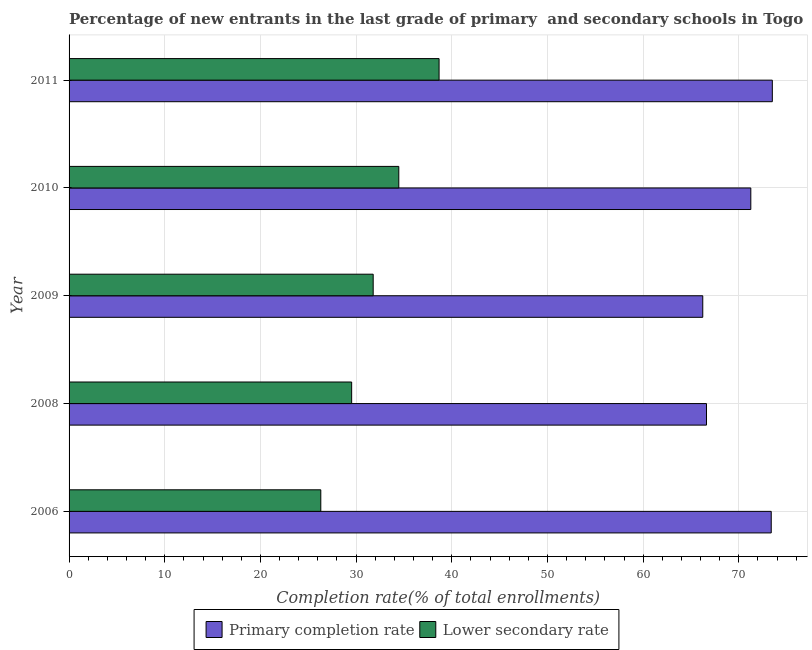Are the number of bars per tick equal to the number of legend labels?
Your answer should be very brief. Yes. How many bars are there on the 2nd tick from the top?
Offer a terse response. 2. How many bars are there on the 2nd tick from the bottom?
Provide a succinct answer. 2. What is the label of the 5th group of bars from the top?
Your response must be concise. 2006. In how many cases, is the number of bars for a given year not equal to the number of legend labels?
Provide a short and direct response. 0. What is the completion rate in primary schools in 2008?
Offer a terse response. 66.62. Across all years, what is the maximum completion rate in primary schools?
Your answer should be very brief. 73.5. Across all years, what is the minimum completion rate in secondary schools?
Offer a very short reply. 26.31. In which year was the completion rate in secondary schools maximum?
Give a very brief answer. 2011. What is the total completion rate in secondary schools in the graph?
Offer a very short reply. 160.77. What is the difference between the completion rate in secondary schools in 2006 and that in 2011?
Keep it short and to the point. -12.36. What is the difference between the completion rate in primary schools in 2008 and the completion rate in secondary schools in 2011?
Your answer should be very brief. 27.95. What is the average completion rate in primary schools per year?
Give a very brief answer. 70.2. In the year 2009, what is the difference between the completion rate in primary schools and completion rate in secondary schools?
Make the answer very short. 34.45. What is the ratio of the completion rate in primary schools in 2006 to that in 2008?
Ensure brevity in your answer.  1.1. Is the difference between the completion rate in secondary schools in 2006 and 2009 greater than the difference between the completion rate in primary schools in 2006 and 2009?
Offer a terse response. No. What is the difference between the highest and the second highest completion rate in secondary schools?
Offer a terse response. 4.21. What is the difference between the highest and the lowest completion rate in primary schools?
Keep it short and to the point. 7.27. What does the 2nd bar from the top in 2008 represents?
Make the answer very short. Primary completion rate. What does the 2nd bar from the bottom in 2008 represents?
Your response must be concise. Lower secondary rate. How many bars are there?
Ensure brevity in your answer.  10. How many years are there in the graph?
Make the answer very short. 5. Does the graph contain any zero values?
Give a very brief answer. No. Does the graph contain grids?
Give a very brief answer. Yes. Where does the legend appear in the graph?
Your answer should be very brief. Bottom center. How many legend labels are there?
Make the answer very short. 2. What is the title of the graph?
Offer a terse response. Percentage of new entrants in the last grade of primary  and secondary schools in Togo. What is the label or title of the X-axis?
Make the answer very short. Completion rate(% of total enrollments). What is the label or title of the Y-axis?
Provide a short and direct response. Year. What is the Completion rate(% of total enrollments) in Primary completion rate in 2006?
Give a very brief answer. 73.39. What is the Completion rate(% of total enrollments) in Lower secondary rate in 2006?
Your answer should be very brief. 26.31. What is the Completion rate(% of total enrollments) in Primary completion rate in 2008?
Make the answer very short. 66.62. What is the Completion rate(% of total enrollments) in Lower secondary rate in 2008?
Give a very brief answer. 29.54. What is the Completion rate(% of total enrollments) in Primary completion rate in 2009?
Offer a terse response. 66.23. What is the Completion rate(% of total enrollments) of Lower secondary rate in 2009?
Offer a very short reply. 31.79. What is the Completion rate(% of total enrollments) in Primary completion rate in 2010?
Your answer should be compact. 71.25. What is the Completion rate(% of total enrollments) of Lower secondary rate in 2010?
Your answer should be compact. 34.46. What is the Completion rate(% of total enrollments) in Primary completion rate in 2011?
Provide a succinct answer. 73.5. What is the Completion rate(% of total enrollments) in Lower secondary rate in 2011?
Your answer should be compact. 38.67. Across all years, what is the maximum Completion rate(% of total enrollments) in Primary completion rate?
Ensure brevity in your answer.  73.5. Across all years, what is the maximum Completion rate(% of total enrollments) of Lower secondary rate?
Make the answer very short. 38.67. Across all years, what is the minimum Completion rate(% of total enrollments) in Primary completion rate?
Provide a short and direct response. 66.23. Across all years, what is the minimum Completion rate(% of total enrollments) of Lower secondary rate?
Ensure brevity in your answer.  26.31. What is the total Completion rate(% of total enrollments) in Primary completion rate in the graph?
Provide a short and direct response. 351. What is the total Completion rate(% of total enrollments) of Lower secondary rate in the graph?
Offer a very short reply. 160.77. What is the difference between the Completion rate(% of total enrollments) of Primary completion rate in 2006 and that in 2008?
Provide a short and direct response. 6.77. What is the difference between the Completion rate(% of total enrollments) of Lower secondary rate in 2006 and that in 2008?
Offer a terse response. -3.23. What is the difference between the Completion rate(% of total enrollments) in Primary completion rate in 2006 and that in 2009?
Keep it short and to the point. 7.16. What is the difference between the Completion rate(% of total enrollments) of Lower secondary rate in 2006 and that in 2009?
Give a very brief answer. -5.48. What is the difference between the Completion rate(% of total enrollments) in Primary completion rate in 2006 and that in 2010?
Your response must be concise. 2.13. What is the difference between the Completion rate(% of total enrollments) of Lower secondary rate in 2006 and that in 2010?
Offer a very short reply. -8.15. What is the difference between the Completion rate(% of total enrollments) of Primary completion rate in 2006 and that in 2011?
Ensure brevity in your answer.  -0.11. What is the difference between the Completion rate(% of total enrollments) in Lower secondary rate in 2006 and that in 2011?
Keep it short and to the point. -12.36. What is the difference between the Completion rate(% of total enrollments) of Primary completion rate in 2008 and that in 2009?
Keep it short and to the point. 0.39. What is the difference between the Completion rate(% of total enrollments) of Lower secondary rate in 2008 and that in 2009?
Offer a terse response. -2.25. What is the difference between the Completion rate(% of total enrollments) in Primary completion rate in 2008 and that in 2010?
Offer a terse response. -4.63. What is the difference between the Completion rate(% of total enrollments) in Lower secondary rate in 2008 and that in 2010?
Your answer should be very brief. -4.93. What is the difference between the Completion rate(% of total enrollments) of Primary completion rate in 2008 and that in 2011?
Provide a short and direct response. -6.88. What is the difference between the Completion rate(% of total enrollments) in Lower secondary rate in 2008 and that in 2011?
Your answer should be compact. -9.14. What is the difference between the Completion rate(% of total enrollments) of Primary completion rate in 2009 and that in 2010?
Your response must be concise. -5.02. What is the difference between the Completion rate(% of total enrollments) in Lower secondary rate in 2009 and that in 2010?
Provide a succinct answer. -2.68. What is the difference between the Completion rate(% of total enrollments) of Primary completion rate in 2009 and that in 2011?
Ensure brevity in your answer.  -7.27. What is the difference between the Completion rate(% of total enrollments) in Lower secondary rate in 2009 and that in 2011?
Provide a succinct answer. -6.89. What is the difference between the Completion rate(% of total enrollments) in Primary completion rate in 2010 and that in 2011?
Provide a short and direct response. -2.25. What is the difference between the Completion rate(% of total enrollments) in Lower secondary rate in 2010 and that in 2011?
Your answer should be compact. -4.21. What is the difference between the Completion rate(% of total enrollments) in Primary completion rate in 2006 and the Completion rate(% of total enrollments) in Lower secondary rate in 2008?
Offer a very short reply. 43.85. What is the difference between the Completion rate(% of total enrollments) in Primary completion rate in 2006 and the Completion rate(% of total enrollments) in Lower secondary rate in 2009?
Keep it short and to the point. 41.6. What is the difference between the Completion rate(% of total enrollments) of Primary completion rate in 2006 and the Completion rate(% of total enrollments) of Lower secondary rate in 2010?
Make the answer very short. 38.93. What is the difference between the Completion rate(% of total enrollments) of Primary completion rate in 2006 and the Completion rate(% of total enrollments) of Lower secondary rate in 2011?
Ensure brevity in your answer.  34.72. What is the difference between the Completion rate(% of total enrollments) in Primary completion rate in 2008 and the Completion rate(% of total enrollments) in Lower secondary rate in 2009?
Provide a succinct answer. 34.84. What is the difference between the Completion rate(% of total enrollments) in Primary completion rate in 2008 and the Completion rate(% of total enrollments) in Lower secondary rate in 2010?
Offer a very short reply. 32.16. What is the difference between the Completion rate(% of total enrollments) in Primary completion rate in 2008 and the Completion rate(% of total enrollments) in Lower secondary rate in 2011?
Your answer should be very brief. 27.95. What is the difference between the Completion rate(% of total enrollments) of Primary completion rate in 2009 and the Completion rate(% of total enrollments) of Lower secondary rate in 2010?
Provide a succinct answer. 31.77. What is the difference between the Completion rate(% of total enrollments) of Primary completion rate in 2009 and the Completion rate(% of total enrollments) of Lower secondary rate in 2011?
Your response must be concise. 27.56. What is the difference between the Completion rate(% of total enrollments) of Primary completion rate in 2010 and the Completion rate(% of total enrollments) of Lower secondary rate in 2011?
Your response must be concise. 32.58. What is the average Completion rate(% of total enrollments) of Primary completion rate per year?
Provide a short and direct response. 70.2. What is the average Completion rate(% of total enrollments) of Lower secondary rate per year?
Your answer should be compact. 32.15. In the year 2006, what is the difference between the Completion rate(% of total enrollments) in Primary completion rate and Completion rate(% of total enrollments) in Lower secondary rate?
Offer a very short reply. 47.08. In the year 2008, what is the difference between the Completion rate(% of total enrollments) in Primary completion rate and Completion rate(% of total enrollments) in Lower secondary rate?
Make the answer very short. 37.09. In the year 2009, what is the difference between the Completion rate(% of total enrollments) in Primary completion rate and Completion rate(% of total enrollments) in Lower secondary rate?
Make the answer very short. 34.45. In the year 2010, what is the difference between the Completion rate(% of total enrollments) in Primary completion rate and Completion rate(% of total enrollments) in Lower secondary rate?
Your answer should be very brief. 36.79. In the year 2011, what is the difference between the Completion rate(% of total enrollments) of Primary completion rate and Completion rate(% of total enrollments) of Lower secondary rate?
Provide a short and direct response. 34.83. What is the ratio of the Completion rate(% of total enrollments) of Primary completion rate in 2006 to that in 2008?
Offer a very short reply. 1.1. What is the ratio of the Completion rate(% of total enrollments) of Lower secondary rate in 2006 to that in 2008?
Keep it short and to the point. 0.89. What is the ratio of the Completion rate(% of total enrollments) in Primary completion rate in 2006 to that in 2009?
Offer a terse response. 1.11. What is the ratio of the Completion rate(% of total enrollments) of Lower secondary rate in 2006 to that in 2009?
Make the answer very short. 0.83. What is the ratio of the Completion rate(% of total enrollments) in Lower secondary rate in 2006 to that in 2010?
Make the answer very short. 0.76. What is the ratio of the Completion rate(% of total enrollments) in Lower secondary rate in 2006 to that in 2011?
Offer a terse response. 0.68. What is the ratio of the Completion rate(% of total enrollments) in Primary completion rate in 2008 to that in 2009?
Provide a succinct answer. 1.01. What is the ratio of the Completion rate(% of total enrollments) in Lower secondary rate in 2008 to that in 2009?
Offer a very short reply. 0.93. What is the ratio of the Completion rate(% of total enrollments) of Primary completion rate in 2008 to that in 2010?
Make the answer very short. 0.94. What is the ratio of the Completion rate(% of total enrollments) of Lower secondary rate in 2008 to that in 2010?
Your answer should be very brief. 0.86. What is the ratio of the Completion rate(% of total enrollments) of Primary completion rate in 2008 to that in 2011?
Ensure brevity in your answer.  0.91. What is the ratio of the Completion rate(% of total enrollments) in Lower secondary rate in 2008 to that in 2011?
Offer a very short reply. 0.76. What is the ratio of the Completion rate(% of total enrollments) in Primary completion rate in 2009 to that in 2010?
Provide a succinct answer. 0.93. What is the ratio of the Completion rate(% of total enrollments) in Lower secondary rate in 2009 to that in 2010?
Your response must be concise. 0.92. What is the ratio of the Completion rate(% of total enrollments) in Primary completion rate in 2009 to that in 2011?
Your answer should be very brief. 0.9. What is the ratio of the Completion rate(% of total enrollments) in Lower secondary rate in 2009 to that in 2011?
Your answer should be very brief. 0.82. What is the ratio of the Completion rate(% of total enrollments) in Primary completion rate in 2010 to that in 2011?
Give a very brief answer. 0.97. What is the ratio of the Completion rate(% of total enrollments) of Lower secondary rate in 2010 to that in 2011?
Make the answer very short. 0.89. What is the difference between the highest and the second highest Completion rate(% of total enrollments) in Primary completion rate?
Offer a very short reply. 0.11. What is the difference between the highest and the second highest Completion rate(% of total enrollments) in Lower secondary rate?
Your answer should be very brief. 4.21. What is the difference between the highest and the lowest Completion rate(% of total enrollments) of Primary completion rate?
Offer a very short reply. 7.27. What is the difference between the highest and the lowest Completion rate(% of total enrollments) of Lower secondary rate?
Give a very brief answer. 12.36. 